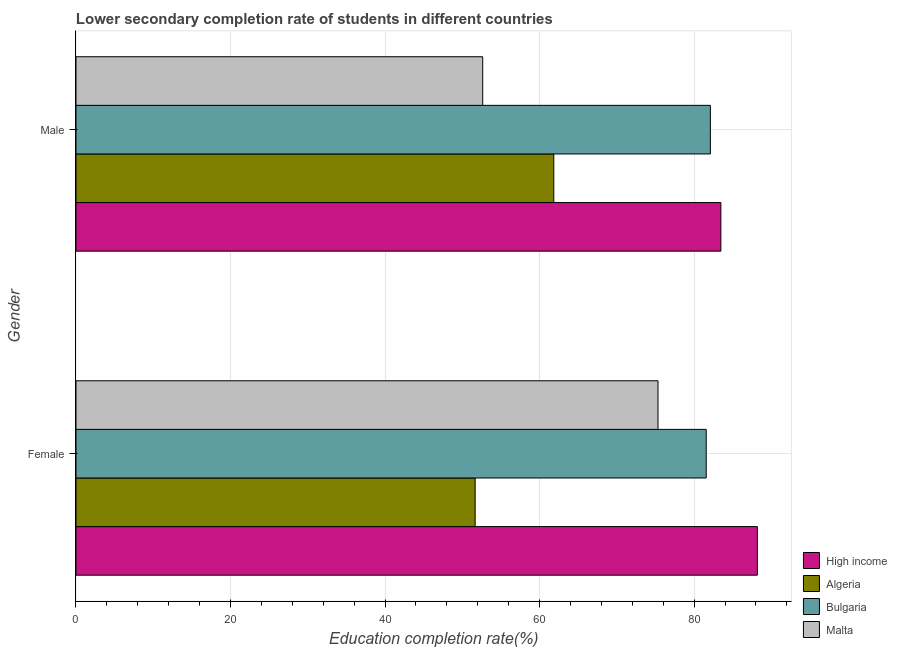Are the number of bars per tick equal to the number of legend labels?
Offer a terse response. Yes. Are the number of bars on each tick of the Y-axis equal?
Ensure brevity in your answer.  Yes. What is the label of the 1st group of bars from the top?
Offer a very short reply. Male. What is the education completion rate of male students in Bulgaria?
Keep it short and to the point. 82.1. Across all countries, what is the maximum education completion rate of female students?
Provide a short and direct response. 88.18. Across all countries, what is the minimum education completion rate of male students?
Provide a short and direct response. 52.64. In which country was the education completion rate of male students minimum?
Ensure brevity in your answer.  Malta. What is the total education completion rate of female students in the graph?
Keep it short and to the point. 296.71. What is the difference between the education completion rate of female students in Malta and that in High income?
Your answer should be very brief. -12.86. What is the difference between the education completion rate of male students in High income and the education completion rate of female students in Algeria?
Ensure brevity in your answer.  31.8. What is the average education completion rate of male students per country?
Ensure brevity in your answer.  70.01. What is the difference between the education completion rate of female students and education completion rate of male students in High income?
Offer a very short reply. 4.72. In how many countries, is the education completion rate of male students greater than 36 %?
Keep it short and to the point. 4. What is the ratio of the education completion rate of female students in Malta to that in Bulgaria?
Give a very brief answer. 0.92. In how many countries, is the education completion rate of male students greater than the average education completion rate of male students taken over all countries?
Give a very brief answer. 2. What does the 2nd bar from the top in Female represents?
Provide a short and direct response. Bulgaria. What does the 4th bar from the bottom in Female represents?
Keep it short and to the point. Malta. Are all the bars in the graph horizontal?
Provide a short and direct response. Yes. Does the graph contain grids?
Provide a succinct answer. Yes. Where does the legend appear in the graph?
Make the answer very short. Bottom right. What is the title of the graph?
Offer a very short reply. Lower secondary completion rate of students in different countries. What is the label or title of the X-axis?
Offer a terse response. Education completion rate(%). What is the Education completion rate(%) of High income in Female?
Your response must be concise. 88.18. What is the Education completion rate(%) of Algeria in Female?
Offer a very short reply. 51.66. What is the Education completion rate(%) in Bulgaria in Female?
Your response must be concise. 81.56. What is the Education completion rate(%) in Malta in Female?
Provide a short and direct response. 75.32. What is the Education completion rate(%) in High income in Male?
Make the answer very short. 83.46. What is the Education completion rate(%) in Algeria in Male?
Keep it short and to the point. 61.83. What is the Education completion rate(%) in Bulgaria in Male?
Make the answer very short. 82.1. What is the Education completion rate(%) of Malta in Male?
Give a very brief answer. 52.64. Across all Gender, what is the maximum Education completion rate(%) in High income?
Give a very brief answer. 88.18. Across all Gender, what is the maximum Education completion rate(%) in Algeria?
Provide a succinct answer. 61.83. Across all Gender, what is the maximum Education completion rate(%) in Bulgaria?
Keep it short and to the point. 82.1. Across all Gender, what is the maximum Education completion rate(%) of Malta?
Your response must be concise. 75.32. Across all Gender, what is the minimum Education completion rate(%) of High income?
Provide a short and direct response. 83.46. Across all Gender, what is the minimum Education completion rate(%) of Algeria?
Provide a short and direct response. 51.66. Across all Gender, what is the minimum Education completion rate(%) in Bulgaria?
Offer a very short reply. 81.56. Across all Gender, what is the minimum Education completion rate(%) of Malta?
Keep it short and to the point. 52.64. What is the total Education completion rate(%) of High income in the graph?
Give a very brief answer. 171.64. What is the total Education completion rate(%) of Algeria in the graph?
Make the answer very short. 113.49. What is the total Education completion rate(%) in Bulgaria in the graph?
Your answer should be very brief. 163.65. What is the total Education completion rate(%) in Malta in the graph?
Provide a short and direct response. 127.96. What is the difference between the Education completion rate(%) in High income in Female and that in Male?
Offer a terse response. 4.72. What is the difference between the Education completion rate(%) of Algeria in Female and that in Male?
Your response must be concise. -10.18. What is the difference between the Education completion rate(%) of Bulgaria in Female and that in Male?
Offer a terse response. -0.54. What is the difference between the Education completion rate(%) of Malta in Female and that in Male?
Make the answer very short. 22.68. What is the difference between the Education completion rate(%) of High income in Female and the Education completion rate(%) of Algeria in Male?
Give a very brief answer. 26.35. What is the difference between the Education completion rate(%) in High income in Female and the Education completion rate(%) in Bulgaria in Male?
Make the answer very short. 6.08. What is the difference between the Education completion rate(%) of High income in Female and the Education completion rate(%) of Malta in Male?
Ensure brevity in your answer.  35.54. What is the difference between the Education completion rate(%) in Algeria in Female and the Education completion rate(%) in Bulgaria in Male?
Offer a very short reply. -30.44. What is the difference between the Education completion rate(%) of Algeria in Female and the Education completion rate(%) of Malta in Male?
Offer a terse response. -0.98. What is the difference between the Education completion rate(%) in Bulgaria in Female and the Education completion rate(%) in Malta in Male?
Your answer should be compact. 28.92. What is the average Education completion rate(%) in High income per Gender?
Offer a very short reply. 85.82. What is the average Education completion rate(%) of Algeria per Gender?
Offer a very short reply. 56.75. What is the average Education completion rate(%) of Bulgaria per Gender?
Ensure brevity in your answer.  81.83. What is the average Education completion rate(%) in Malta per Gender?
Your response must be concise. 63.98. What is the difference between the Education completion rate(%) of High income and Education completion rate(%) of Algeria in Female?
Offer a terse response. 36.52. What is the difference between the Education completion rate(%) in High income and Education completion rate(%) in Bulgaria in Female?
Give a very brief answer. 6.62. What is the difference between the Education completion rate(%) of High income and Education completion rate(%) of Malta in Female?
Offer a very short reply. 12.86. What is the difference between the Education completion rate(%) in Algeria and Education completion rate(%) in Bulgaria in Female?
Ensure brevity in your answer.  -29.9. What is the difference between the Education completion rate(%) of Algeria and Education completion rate(%) of Malta in Female?
Give a very brief answer. -23.66. What is the difference between the Education completion rate(%) in Bulgaria and Education completion rate(%) in Malta in Female?
Offer a terse response. 6.24. What is the difference between the Education completion rate(%) of High income and Education completion rate(%) of Algeria in Male?
Make the answer very short. 21.62. What is the difference between the Education completion rate(%) of High income and Education completion rate(%) of Bulgaria in Male?
Ensure brevity in your answer.  1.36. What is the difference between the Education completion rate(%) in High income and Education completion rate(%) in Malta in Male?
Offer a terse response. 30.82. What is the difference between the Education completion rate(%) of Algeria and Education completion rate(%) of Bulgaria in Male?
Make the answer very short. -20.26. What is the difference between the Education completion rate(%) in Algeria and Education completion rate(%) in Malta in Male?
Ensure brevity in your answer.  9.2. What is the difference between the Education completion rate(%) of Bulgaria and Education completion rate(%) of Malta in Male?
Provide a short and direct response. 29.46. What is the ratio of the Education completion rate(%) of High income in Female to that in Male?
Provide a succinct answer. 1.06. What is the ratio of the Education completion rate(%) in Algeria in Female to that in Male?
Provide a succinct answer. 0.84. What is the ratio of the Education completion rate(%) of Bulgaria in Female to that in Male?
Keep it short and to the point. 0.99. What is the ratio of the Education completion rate(%) in Malta in Female to that in Male?
Make the answer very short. 1.43. What is the difference between the highest and the second highest Education completion rate(%) in High income?
Offer a terse response. 4.72. What is the difference between the highest and the second highest Education completion rate(%) of Algeria?
Your answer should be compact. 10.18. What is the difference between the highest and the second highest Education completion rate(%) of Bulgaria?
Your response must be concise. 0.54. What is the difference between the highest and the second highest Education completion rate(%) in Malta?
Your answer should be compact. 22.68. What is the difference between the highest and the lowest Education completion rate(%) of High income?
Make the answer very short. 4.72. What is the difference between the highest and the lowest Education completion rate(%) in Algeria?
Give a very brief answer. 10.18. What is the difference between the highest and the lowest Education completion rate(%) in Bulgaria?
Keep it short and to the point. 0.54. What is the difference between the highest and the lowest Education completion rate(%) in Malta?
Your response must be concise. 22.68. 